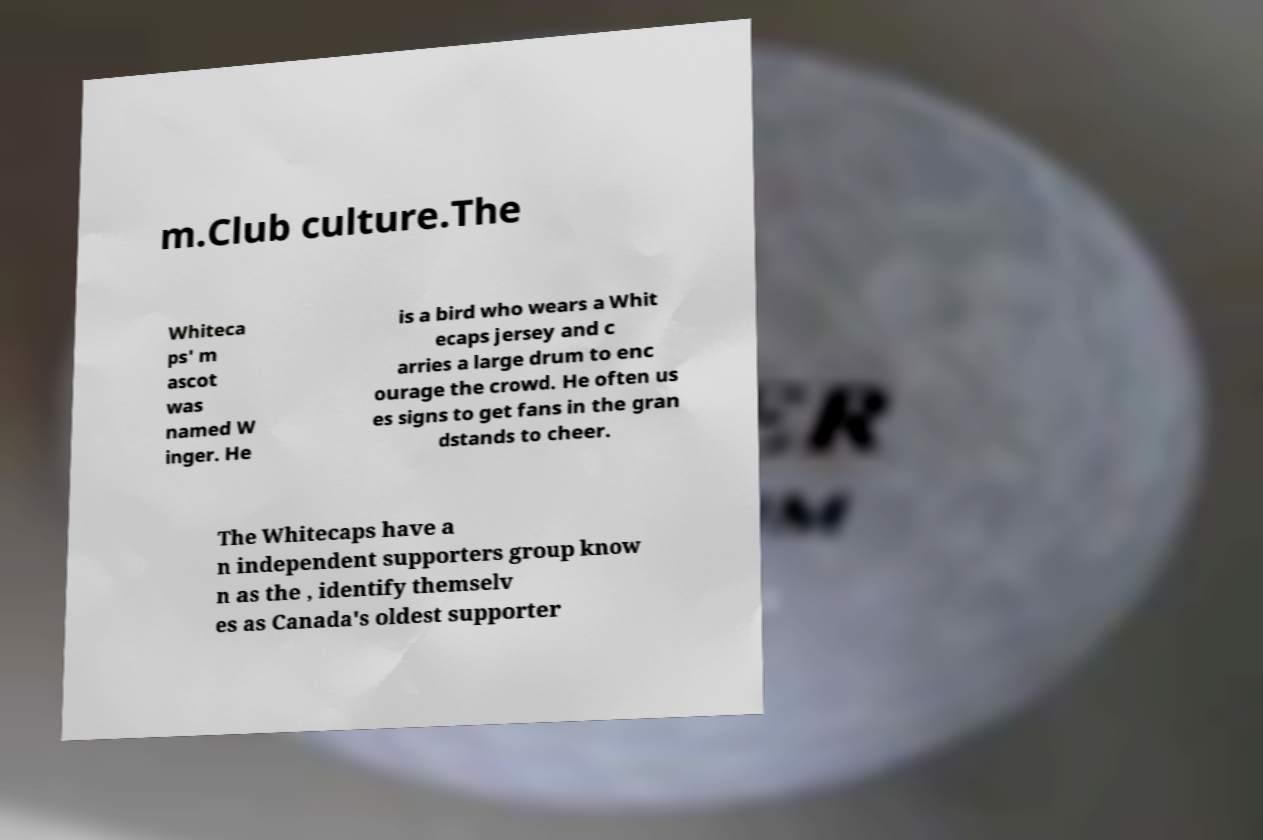Could you extract and type out the text from this image? m.Club culture.The Whiteca ps' m ascot was named W inger. He is a bird who wears a Whit ecaps jersey and c arries a large drum to enc ourage the crowd. He often us es signs to get fans in the gran dstands to cheer. The Whitecaps have a n independent supporters group know n as the , identify themselv es as Canada's oldest supporter 